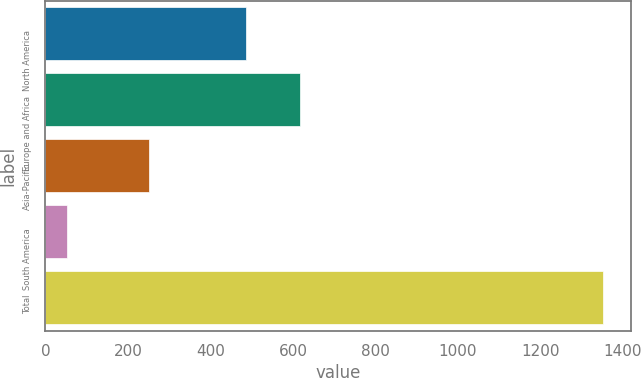Convert chart. <chart><loc_0><loc_0><loc_500><loc_500><bar_chart><fcel>North America<fcel>Europe and Africa<fcel>Asia-Pacific<fcel>South America<fcel>Total<nl><fcel>487<fcel>617<fcel>251<fcel>52<fcel>1352<nl></chart> 